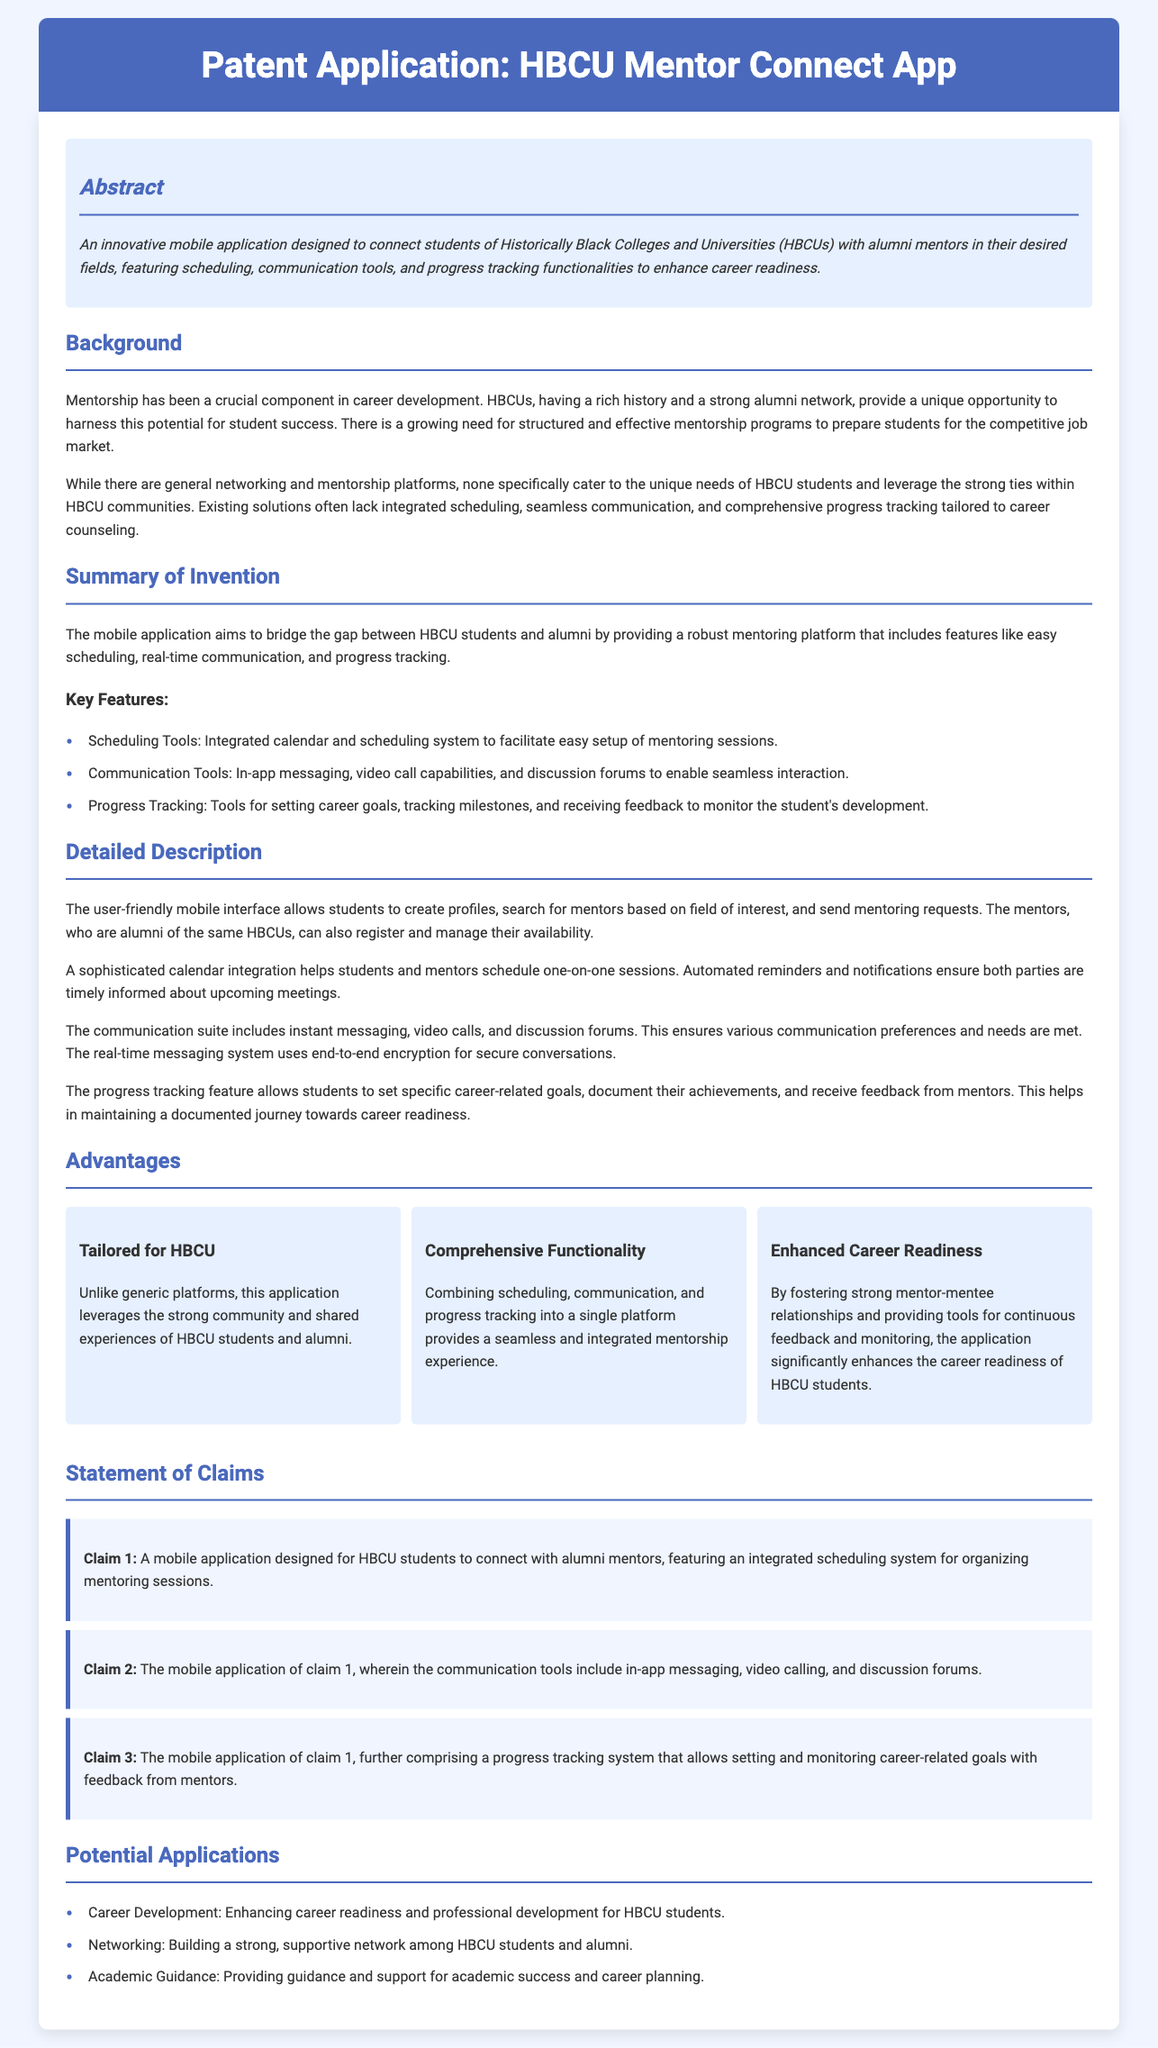What is the title of the patent application? The title is clearly stated at the top of the document as "Patent Application: HBCU Mentor Connect App."
Answer: HBCU Mentor Connect App Who is the target user of the mobile application? The abstract specifies that the application is designed for "students of Traditionally Black Colleges and Universities (HBCUs)."
Answer: HBCU students What are the key features of the application? The section titled "Key Features" lists three main features: scheduling tools, communication tools, and progress tracking.
Answer: Scheduling, communication, progress tracking What does the progress tracking feature allow students to do? The detailed description explains that the progress tracking feature allows students to "set specific career-related goals, document their achievements, and receive feedback from mentors."
Answer: Set goals, document achievements, receive feedback What is the first claim made in the Statement of Claims? Claim 1 mentions the core functionality of the application, which is a mobile application designed for HBCU students to connect with alumni mentors.
Answer: A mobile application designed for HBCU students to connect with alumni mentors Which advantage emphasizes community support? The advantage focusing on community is clearly stated in the section on Advantages as "Tailored for HBCU."
Answer: Tailored for HBCU How many advantages are listed in total? The Advantages section consists of three distinct advantages that are mentioned, clearly numbered in the document.
Answer: Three What potential application is mentioned related to networking? The last part of the document lists potential applications, and one of them pertains specifically to building a strong network.
Answer: Networking What feature ensures secure conversations? The detailed description highlights that the "real-time messaging system uses end-to-end encryption for secure conversations."
Answer: End-to-end encryption 